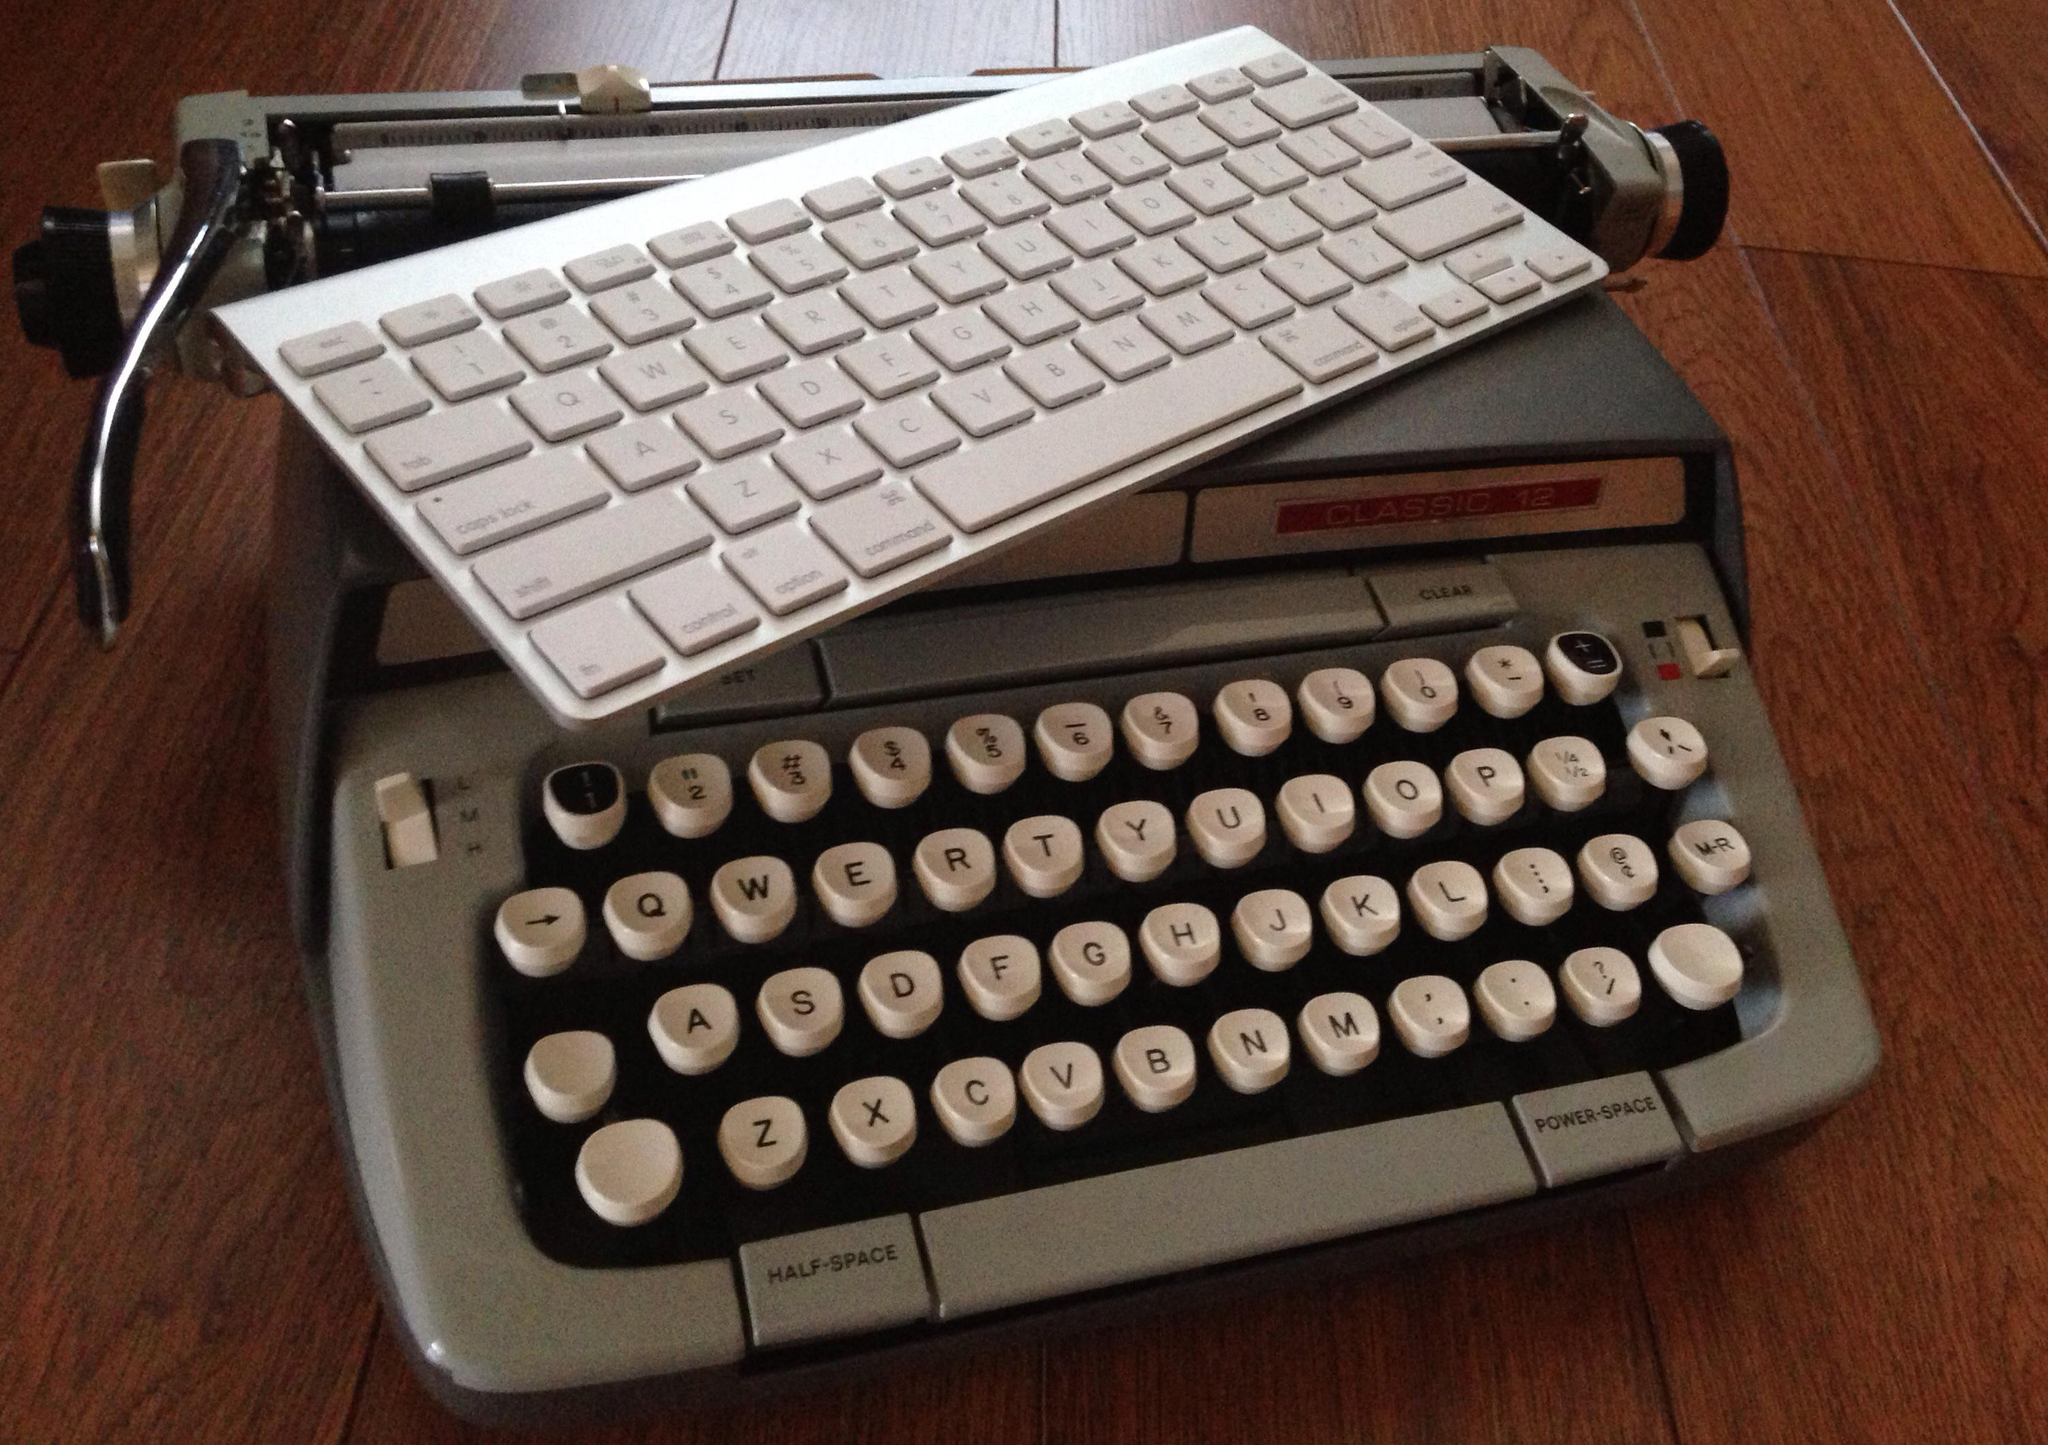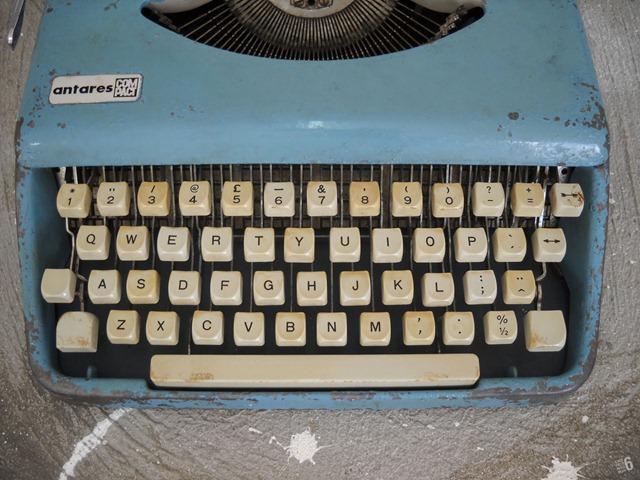The first image is the image on the left, the second image is the image on the right. For the images shown, is this caption "Several keyboards appear in at least one of the images." true? Answer yes or no. Yes. 